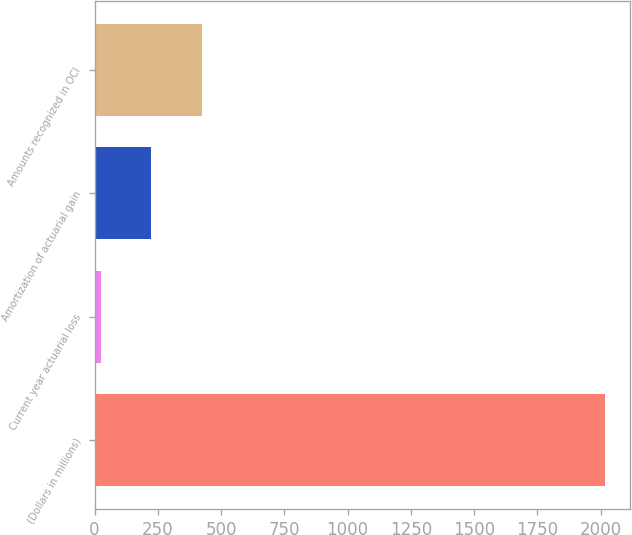Convert chart to OTSL. <chart><loc_0><loc_0><loc_500><loc_500><bar_chart><fcel>(Dollars in millions)<fcel>Current year actuarial loss<fcel>Amortization of actuarial gain<fcel>Amounts recognized in OCI<nl><fcel>2016<fcel>25<fcel>224.1<fcel>423.2<nl></chart> 